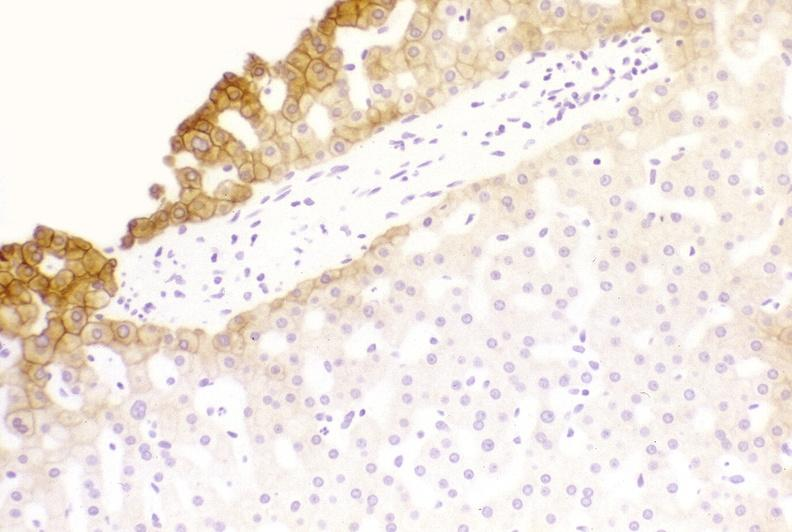what does this image show?
Answer the question using a single word or phrase. Low molecular weight keratin 